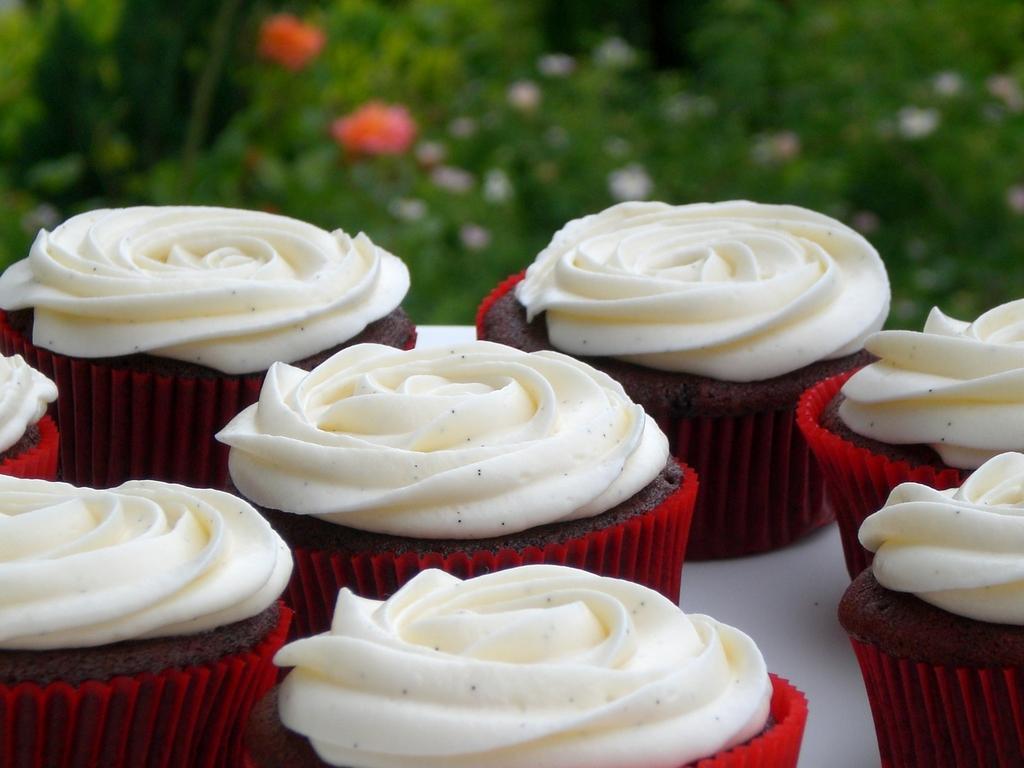Could you give a brief overview of what you see in this image? In the image we can see there are cup cakes and there is cream on top of the cupcakes kept on the table. Behind there are flowers on the plants and the image is little blurry at the back. 